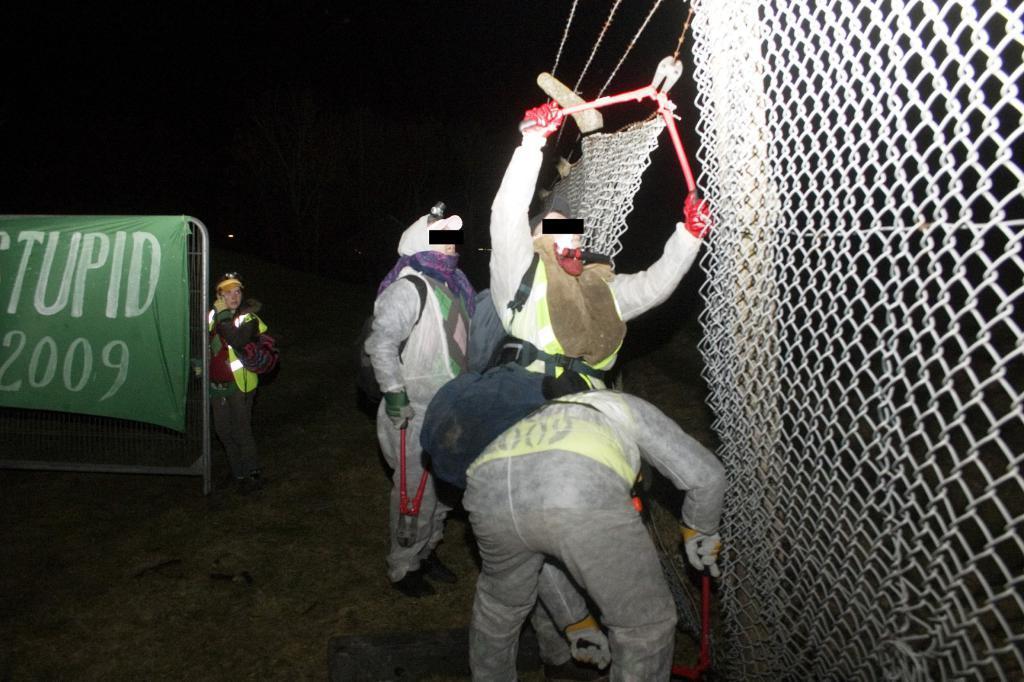In one or two sentences, can you explain what this image depicts? In this image we can see a group of people cutting the fence, behind them there is a poster with some text on it and a person is standing behind it. 